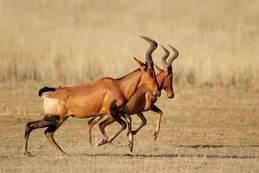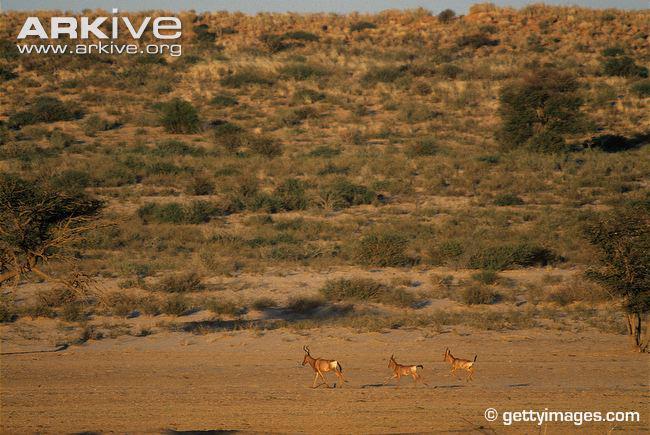The first image is the image on the left, the second image is the image on the right. Examine the images to the left and right. Is the description "The left and right image contains the same number of antelopes." accurate? Answer yes or no. No. 